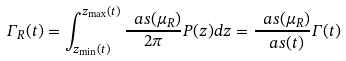Convert formula to latex. <formula><loc_0><loc_0><loc_500><loc_500>\Gamma _ { R } ( t ) = \int _ { z _ { \min } ( t ) } ^ { z _ { \max } ( t ) } \frac { \ a s ( \mu _ { R } ) } { 2 \pi } P ( z ) d z = \frac { \ a s ( \mu _ { R } ) } { \ a s ( t ) } \Gamma ( t )</formula> 